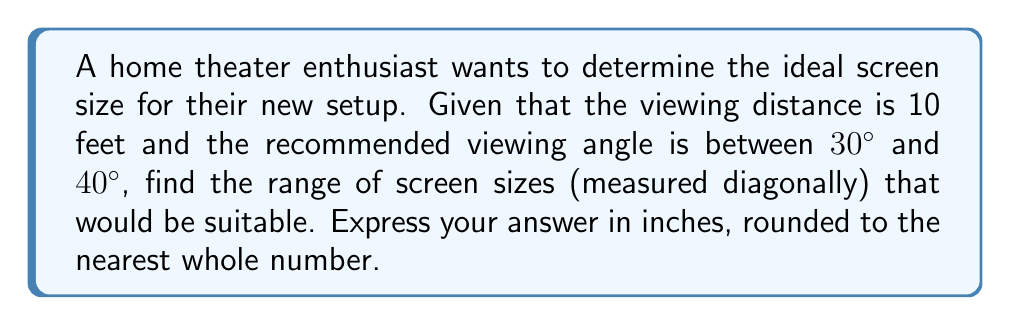Solve this math problem. Let's approach this step-by-step:

1) First, we need to understand the relationship between screen size, viewing distance, and viewing angle. This is given by the formula:

   $$\tan(\frac{\theta}{2}) = \frac{w}{2d}$$

   where $\theta$ is the viewing angle, $w$ is the screen width, and $d$ is the viewing distance.

2) We're given the viewing distance $d = 10$ feet, and we need to find the screen size for angles between 30° and 40°.

3) The screen size is measured diagonally, but our formula uses width. For a 16:9 aspect ratio (common for HDTVs), the relationship between diagonal (s) and width (w) is:

   $$w = \frac{15.7s}{18}$$

4) Substituting this into our original formula:

   $$\tan(\frac{\theta}{2}) = \frac{15.7s}{36d}$$

5) Solving for s:

   $$s = \frac{36d \tan(\frac{\theta}{2})}{15.7}$$

6) Now, let's calculate for both 30° and 40°:

   For 30°: $$s = \frac{36 \cdot 10 \cdot \tan(15°)}{15.7} \approx 61.5 \text{ inches}$$

   For 40°: $$s = \frac{36 \cdot 10 \cdot \tan(20°)}{15.7} \approx 83.3 \text{ inches}$$

7) Rounding to the nearest whole number:
   The range is 62 inches to 83 inches.
Answer: 62 to 83 inches 